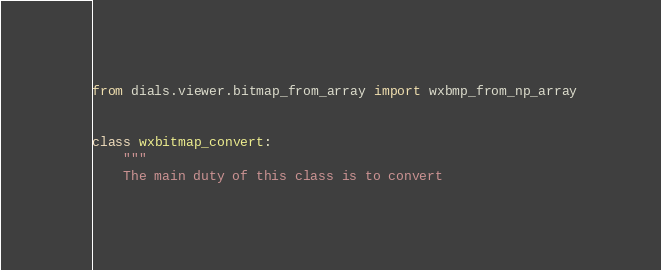<code> <loc_0><loc_0><loc_500><loc_500><_Python_>from dials.viewer.bitmap_from_array import wxbmp_from_np_array


class wxbitmap_convert:
    """
    The main duty of this class is to convert</code> 